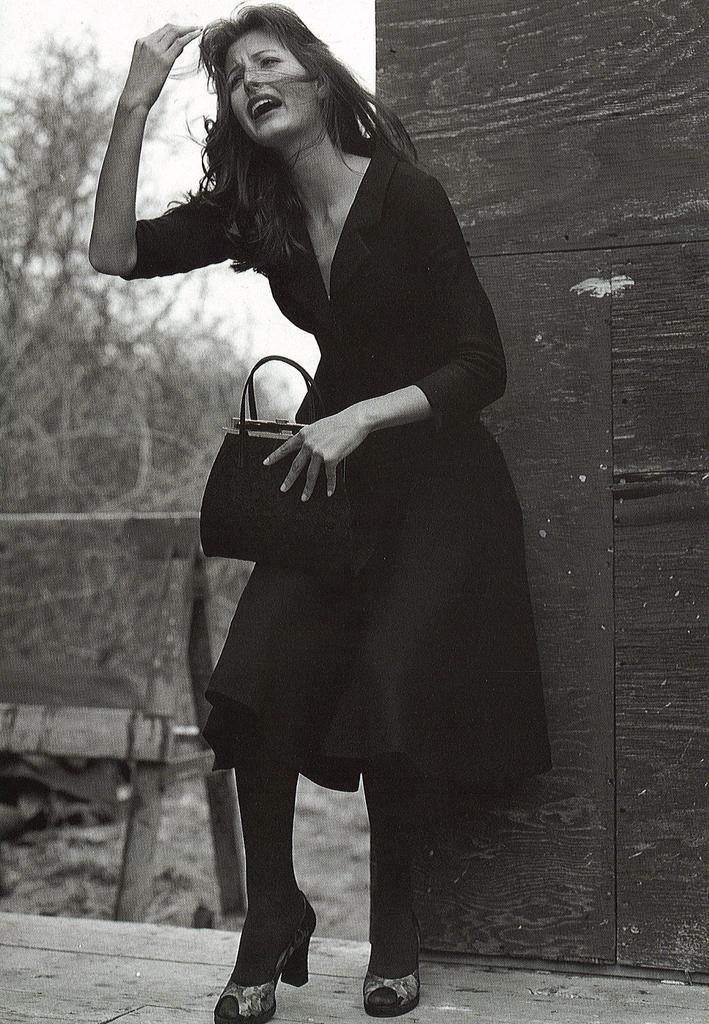Please provide a concise description of this image. In this image I see a woman who is standing and she is holding a bag and she is on the path. In the background I see the plants and the wall. 